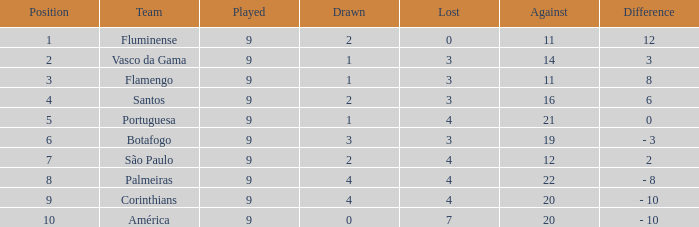Which Against is the highest one that has a Difference of 12? 11.0. 